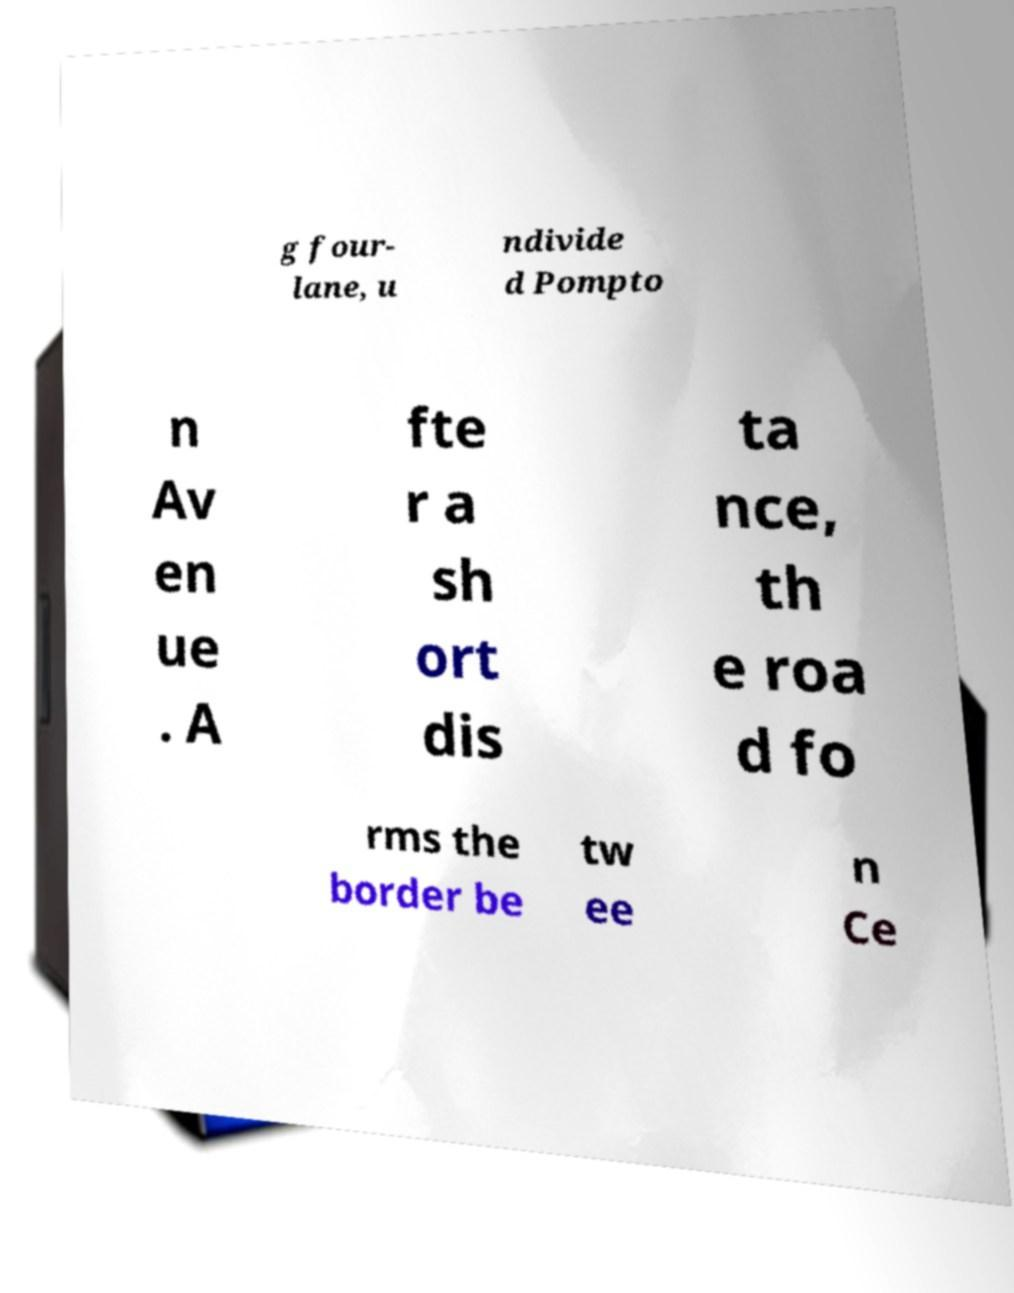What messages or text are displayed in this image? I need them in a readable, typed format. g four- lane, u ndivide d Pompto n Av en ue . A fte r a sh ort dis ta nce, th e roa d fo rms the border be tw ee n Ce 